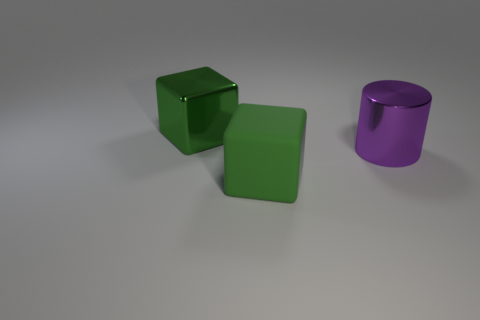Add 2 big rubber objects. How many objects exist? 5 Subtract all cylinders. How many objects are left? 2 Add 3 cubes. How many cubes are left? 5 Add 2 blue blocks. How many blue blocks exist? 2 Subtract 0 brown cylinders. How many objects are left? 3 Subtract all tiny purple rubber cubes. Subtract all green matte cubes. How many objects are left? 2 